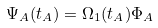Convert formula to latex. <formula><loc_0><loc_0><loc_500><loc_500>\Psi _ { A } ( t _ { A } ) = \Omega _ { 1 } ( t _ { A } ) \Phi _ { A }</formula> 